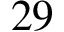Convert formula to latex. <formula><loc_0><loc_0><loc_500><loc_500>2 9</formula> 